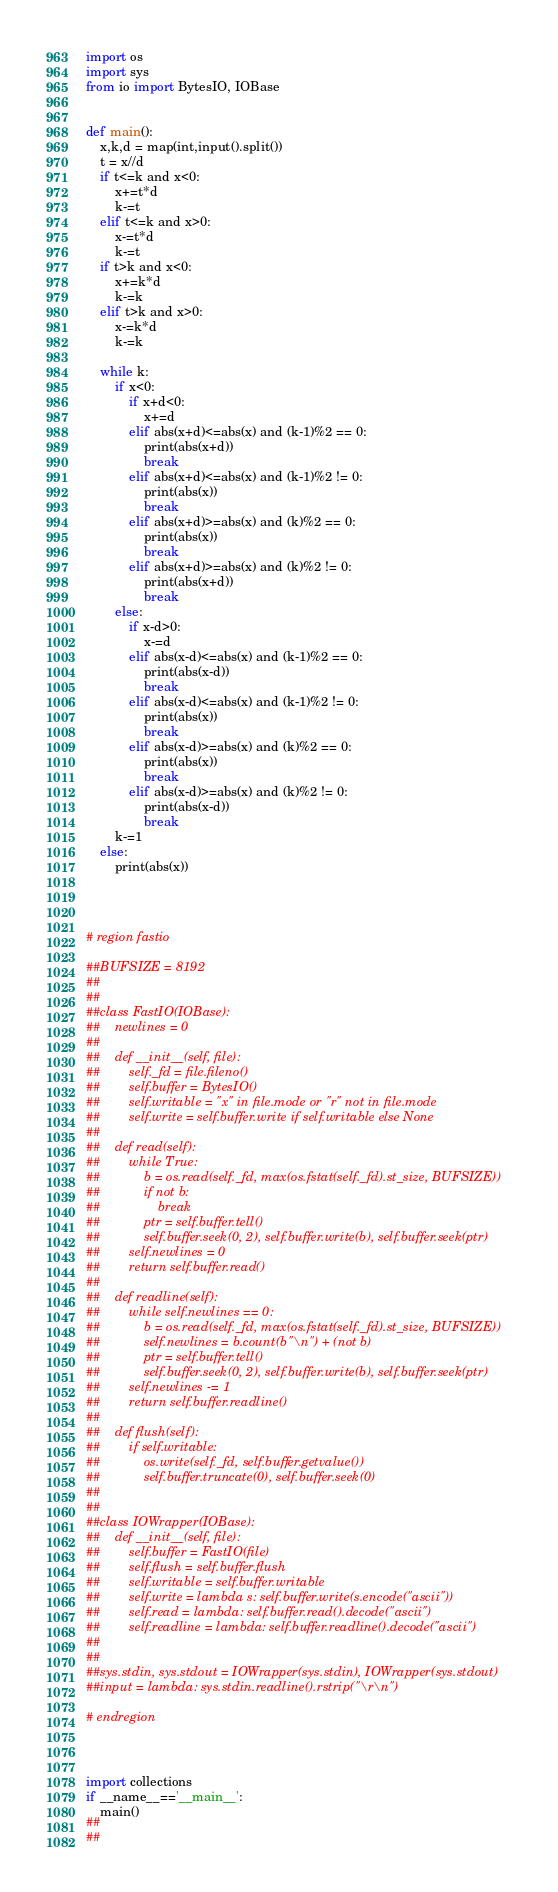Convert code to text. <code><loc_0><loc_0><loc_500><loc_500><_Python_>import os
import sys
from io import BytesIO, IOBase


def main():
    x,k,d = map(int,input().split())
    t = x//d
    if t<=k and x<0:
        x+=t*d
        k-=t
    elif t<=k and x>0:
        x-=t*d
        k-=t
    if t>k and x<0:
        x+=k*d
        k-=k
    elif t>k and x>0:
        x-=k*d
        k-=k
    
    while k:
        if x<0:
            if x+d<0:
                x+=d
            elif abs(x+d)<=abs(x) and (k-1)%2 == 0:
                print(abs(x+d))
                break
            elif abs(x+d)<=abs(x) and (k-1)%2 != 0:
                print(abs(x))
                break
            elif abs(x+d)>=abs(x) and (k)%2 == 0:
                print(abs(x))
                break
            elif abs(x+d)>=abs(x) and (k)%2 != 0:
                print(abs(x+d))
                break
        else:
            if x-d>0:
                x-=d
            elif abs(x-d)<=abs(x) and (k-1)%2 == 0:
                print(abs(x-d))
                break
            elif abs(x-d)<=abs(x) and (k-1)%2 != 0:
                print(abs(x))
                break
            elif abs(x-d)>=abs(x) and (k)%2 == 0:
                print(abs(x))
                break
            elif abs(x-d)>=abs(x) and (k)%2 != 0:
                print(abs(x-d))
                break
        k-=1
    else:
        print(abs(x))
            
        
    

# region fastio

##BUFSIZE = 8192
##
##
##class FastIO(IOBase):
##    newlines = 0
##
##    def __init__(self, file):
##        self._fd = file.fileno()
##        self.buffer = BytesIO()
##        self.writable = "x" in file.mode or "r" not in file.mode
##        self.write = self.buffer.write if self.writable else None
##
##    def read(self):
##        while True:
##            b = os.read(self._fd, max(os.fstat(self._fd).st_size, BUFSIZE))
##            if not b:
##                break
##            ptr = self.buffer.tell()
##            self.buffer.seek(0, 2), self.buffer.write(b), self.buffer.seek(ptr)
##        self.newlines = 0
##        return self.buffer.read()
##
##    def readline(self):
##        while self.newlines == 0:
##            b = os.read(self._fd, max(os.fstat(self._fd).st_size, BUFSIZE))
##            self.newlines = b.count(b"\n") + (not b)
##            ptr = self.buffer.tell()
##            self.buffer.seek(0, 2), self.buffer.write(b), self.buffer.seek(ptr)
##        self.newlines -= 1
##        return self.buffer.readline()
##
##    def flush(self):
##        if self.writable:
##            os.write(self._fd, self.buffer.getvalue())
##            self.buffer.truncate(0), self.buffer.seek(0)
##
##
##class IOWrapper(IOBase):
##    def __init__(self, file):
##        self.buffer = FastIO(file)
##        self.flush = self.buffer.flush
##        self.writable = self.buffer.writable
##        self.write = lambda s: self.buffer.write(s.encode("ascii"))
##        self.read = lambda: self.buffer.read().decode("ascii")
##        self.readline = lambda: self.buffer.readline().decode("ascii")
##
##
##sys.stdin, sys.stdout = IOWrapper(sys.stdin), IOWrapper(sys.stdout)
##input = lambda: sys.stdin.readline().rstrip("\r\n")

# endregion



import collections
if __name__=='__main__':
    main()
##    
##                    
</code> 